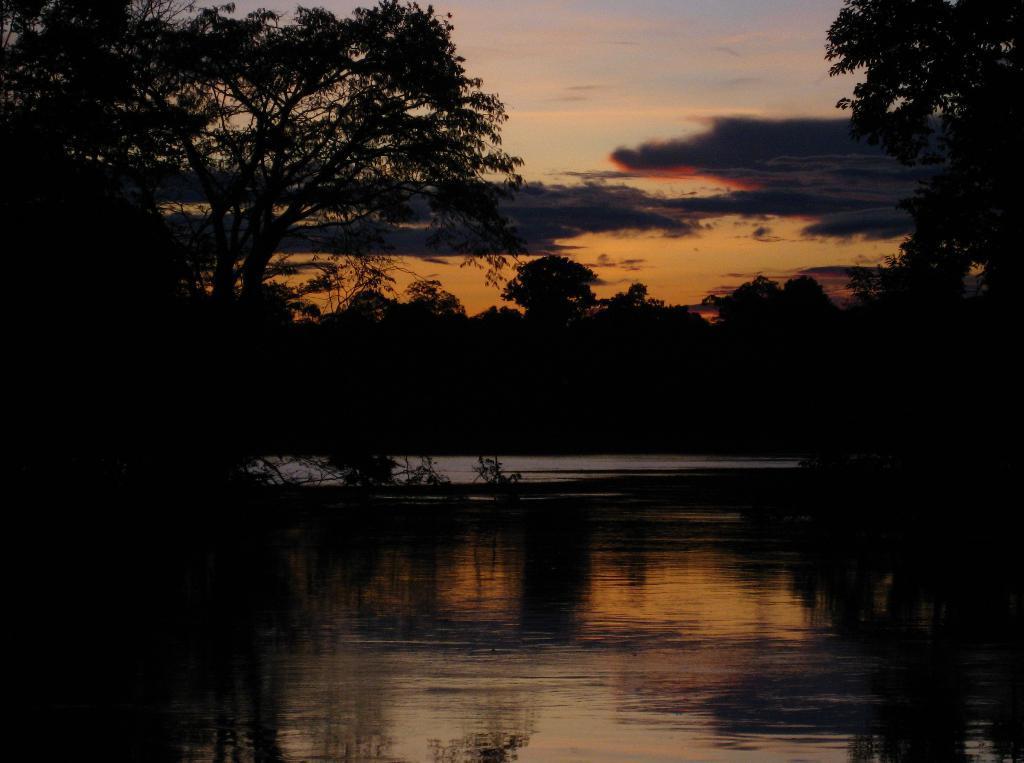Could you give a brief overview of what you see in this image? In the picture we can see the water on either sides of the water we can see plants, trees and in the background also we can see trees and sky with clouds. 